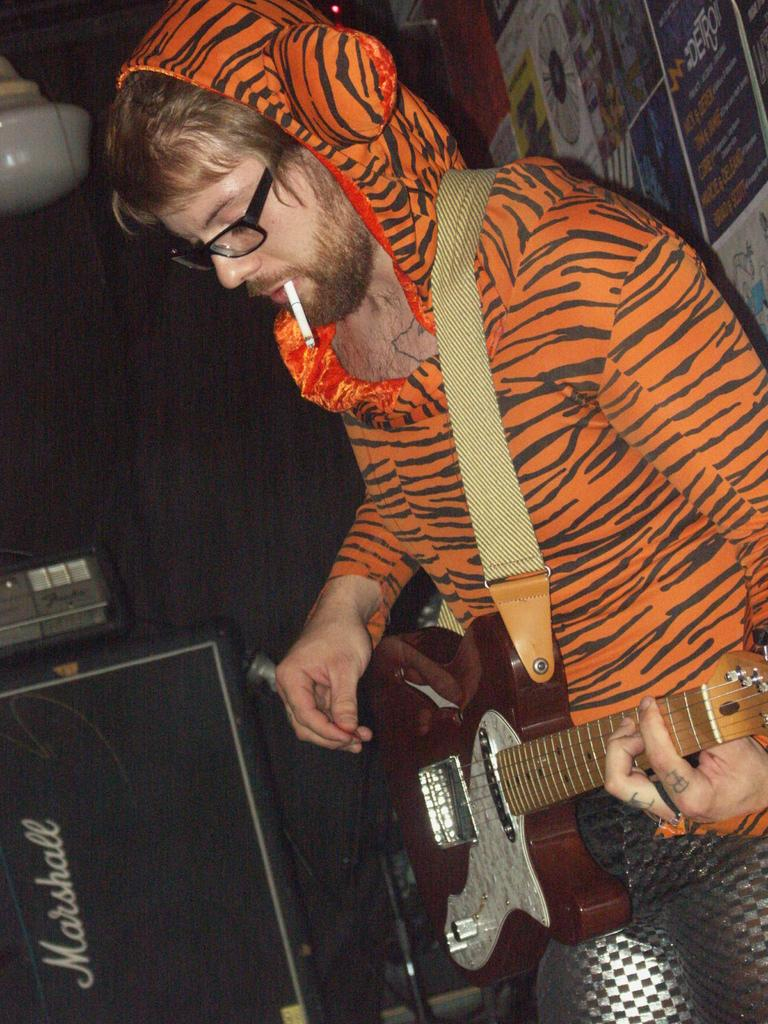What is the person in the image doing? The person is holding a guitar in the image. What can be seen on the person's face? The person is wearing spectacles in the image. What object is present in the image that is related to smoking? There is a cigarette in the image. What type of map can be seen in the image? There is no map present in the image. What authority figure is depicted in the image? There is no authority figure present in the image. 